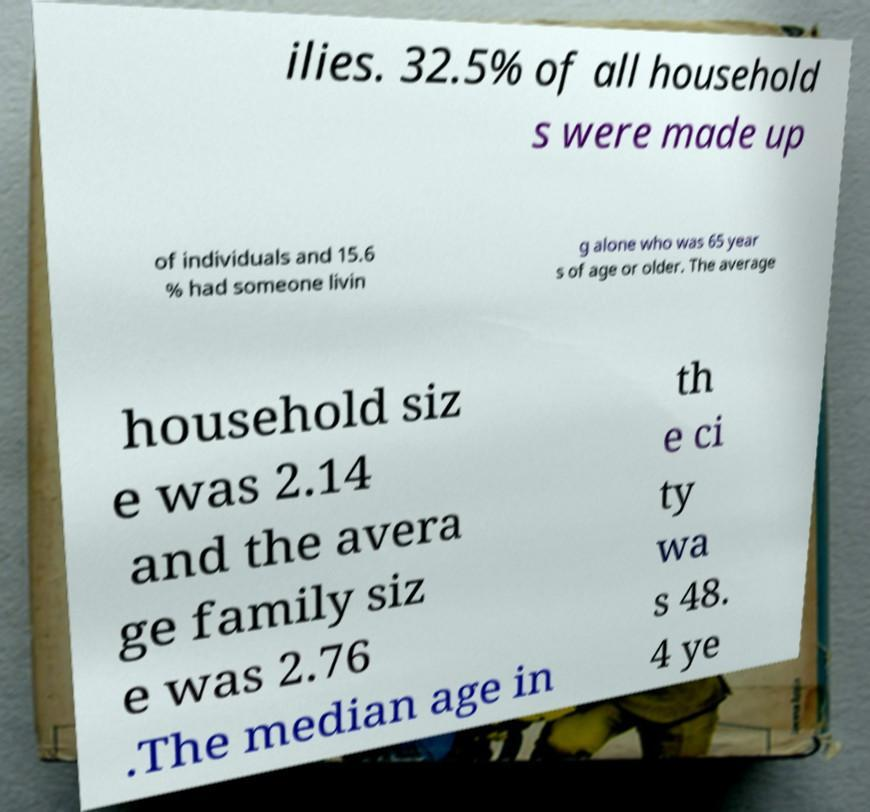Could you assist in decoding the text presented in this image and type it out clearly? ilies. 32.5% of all household s were made up of individuals and 15.6 % had someone livin g alone who was 65 year s of age or older. The average household siz e was 2.14 and the avera ge family siz e was 2.76 .The median age in th e ci ty wa s 48. 4 ye 